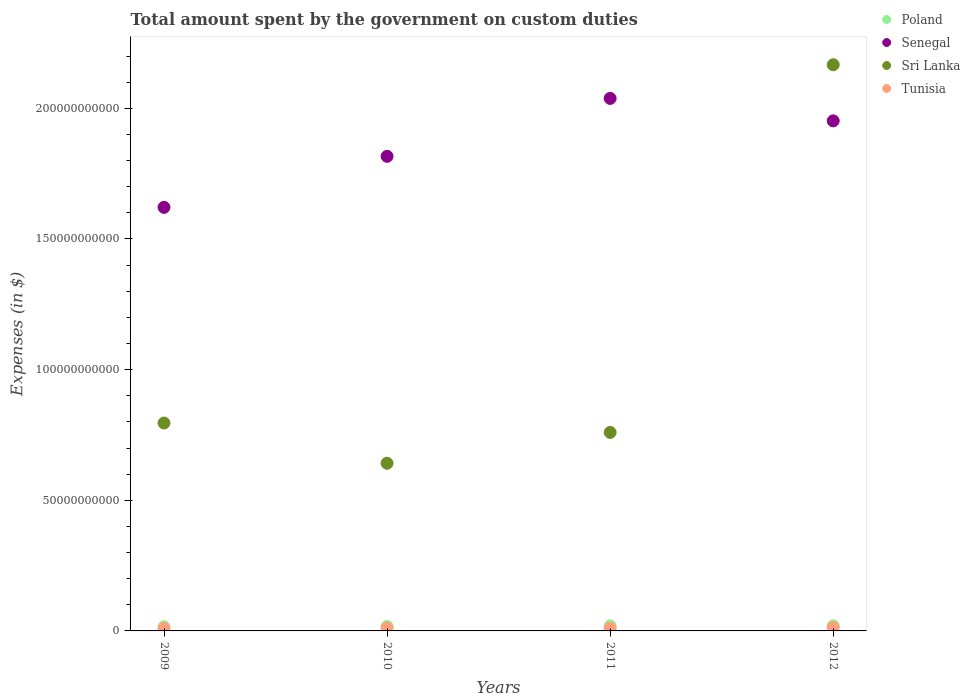What is the amount spent on custom duties by the government in Poland in 2012?
Your response must be concise. 1.95e+09. Across all years, what is the maximum amount spent on custom duties by the government in Tunisia?
Ensure brevity in your answer.  1.31e+09. Across all years, what is the minimum amount spent on custom duties by the government in Tunisia?
Offer a terse response. 9.72e+08. In which year was the amount spent on custom duties by the government in Poland maximum?
Keep it short and to the point. 2011. What is the total amount spent on custom duties by the government in Tunisia in the graph?
Provide a short and direct response. 4.47e+09. What is the difference between the amount spent on custom duties by the government in Sri Lanka in 2010 and that in 2011?
Provide a short and direct response. -1.18e+1. What is the difference between the amount spent on custom duties by the government in Poland in 2010 and the amount spent on custom duties by the government in Senegal in 2009?
Keep it short and to the point. -1.60e+11. What is the average amount spent on custom duties by the government in Tunisia per year?
Offer a very short reply. 1.12e+09. In the year 2010, what is the difference between the amount spent on custom duties by the government in Senegal and amount spent on custom duties by the government in Tunisia?
Keep it short and to the point. 1.80e+11. What is the ratio of the amount spent on custom duties by the government in Senegal in 2009 to that in 2012?
Your answer should be compact. 0.83. Is the difference between the amount spent on custom duties by the government in Senegal in 2010 and 2012 greater than the difference between the amount spent on custom duties by the government in Tunisia in 2010 and 2012?
Provide a succinct answer. No. What is the difference between the highest and the second highest amount spent on custom duties by the government in Sri Lanka?
Offer a terse response. 1.37e+11. What is the difference between the highest and the lowest amount spent on custom duties by the government in Poland?
Offer a terse response. 3.66e+08. Is the sum of the amount spent on custom duties by the government in Senegal in 2010 and 2011 greater than the maximum amount spent on custom duties by the government in Sri Lanka across all years?
Provide a short and direct response. Yes. Is it the case that in every year, the sum of the amount spent on custom duties by the government in Poland and amount spent on custom duties by the government in Senegal  is greater than the sum of amount spent on custom duties by the government in Tunisia and amount spent on custom duties by the government in Sri Lanka?
Provide a succinct answer. Yes. Does the amount spent on custom duties by the government in Poland monotonically increase over the years?
Make the answer very short. No. How many dotlines are there?
Keep it short and to the point. 4. What is the difference between two consecutive major ticks on the Y-axis?
Your response must be concise. 5.00e+1. Are the values on the major ticks of Y-axis written in scientific E-notation?
Keep it short and to the point. No. Does the graph contain grids?
Provide a succinct answer. No. How many legend labels are there?
Your answer should be very brief. 4. What is the title of the graph?
Your answer should be compact. Total amount spent by the government on custom duties. Does "Honduras" appear as one of the legend labels in the graph?
Your response must be concise. No. What is the label or title of the X-axis?
Offer a very short reply. Years. What is the label or title of the Y-axis?
Your response must be concise. Expenses (in $). What is the Expenses (in $) of Poland in 2009?
Offer a very short reply. 1.59e+09. What is the Expenses (in $) in Senegal in 2009?
Your answer should be compact. 1.62e+11. What is the Expenses (in $) in Sri Lanka in 2009?
Offer a very short reply. 7.96e+1. What is the Expenses (in $) in Tunisia in 2009?
Provide a succinct answer. 9.72e+08. What is the Expenses (in $) of Poland in 2010?
Keep it short and to the point. 1.69e+09. What is the Expenses (in $) in Senegal in 2010?
Your answer should be compact. 1.82e+11. What is the Expenses (in $) in Sri Lanka in 2010?
Your answer should be very brief. 6.42e+1. What is the Expenses (in $) in Tunisia in 2010?
Give a very brief answer. 1.13e+09. What is the Expenses (in $) in Poland in 2011?
Keep it short and to the point. 1.96e+09. What is the Expenses (in $) of Senegal in 2011?
Provide a succinct answer. 2.04e+11. What is the Expenses (in $) in Sri Lanka in 2011?
Offer a terse response. 7.60e+1. What is the Expenses (in $) of Tunisia in 2011?
Provide a succinct answer. 1.06e+09. What is the Expenses (in $) in Poland in 2012?
Offer a very short reply. 1.95e+09. What is the Expenses (in $) of Senegal in 2012?
Offer a terse response. 1.95e+11. What is the Expenses (in $) of Sri Lanka in 2012?
Your answer should be very brief. 2.17e+11. What is the Expenses (in $) in Tunisia in 2012?
Ensure brevity in your answer.  1.31e+09. Across all years, what is the maximum Expenses (in $) of Poland?
Keep it short and to the point. 1.96e+09. Across all years, what is the maximum Expenses (in $) of Senegal?
Ensure brevity in your answer.  2.04e+11. Across all years, what is the maximum Expenses (in $) in Sri Lanka?
Offer a very short reply. 2.17e+11. Across all years, what is the maximum Expenses (in $) in Tunisia?
Make the answer very short. 1.31e+09. Across all years, what is the minimum Expenses (in $) in Poland?
Provide a succinct answer. 1.59e+09. Across all years, what is the minimum Expenses (in $) in Senegal?
Offer a terse response. 1.62e+11. Across all years, what is the minimum Expenses (in $) of Sri Lanka?
Your response must be concise. 6.42e+1. Across all years, what is the minimum Expenses (in $) in Tunisia?
Provide a succinct answer. 9.72e+08. What is the total Expenses (in $) in Poland in the graph?
Your answer should be compact. 7.19e+09. What is the total Expenses (in $) of Senegal in the graph?
Provide a short and direct response. 7.43e+11. What is the total Expenses (in $) in Sri Lanka in the graph?
Your answer should be compact. 4.36e+11. What is the total Expenses (in $) in Tunisia in the graph?
Your answer should be compact. 4.47e+09. What is the difference between the Expenses (in $) of Poland in 2009 and that in 2010?
Your answer should be very brief. -1.05e+08. What is the difference between the Expenses (in $) in Senegal in 2009 and that in 2010?
Offer a very short reply. -1.95e+1. What is the difference between the Expenses (in $) of Sri Lanka in 2009 and that in 2010?
Give a very brief answer. 1.54e+1. What is the difference between the Expenses (in $) in Tunisia in 2009 and that in 2010?
Ensure brevity in your answer.  -1.53e+08. What is the difference between the Expenses (in $) in Poland in 2009 and that in 2011?
Keep it short and to the point. -3.66e+08. What is the difference between the Expenses (in $) of Senegal in 2009 and that in 2011?
Provide a short and direct response. -4.17e+1. What is the difference between the Expenses (in $) in Sri Lanka in 2009 and that in 2011?
Your response must be concise. 3.59e+09. What is the difference between the Expenses (in $) of Tunisia in 2009 and that in 2011?
Offer a very short reply. -8.71e+07. What is the difference between the Expenses (in $) of Poland in 2009 and that in 2012?
Your answer should be very brief. -3.61e+08. What is the difference between the Expenses (in $) in Senegal in 2009 and that in 2012?
Your answer should be very brief. -3.31e+1. What is the difference between the Expenses (in $) of Sri Lanka in 2009 and that in 2012?
Your answer should be very brief. -1.37e+11. What is the difference between the Expenses (in $) of Tunisia in 2009 and that in 2012?
Offer a very short reply. -3.41e+08. What is the difference between the Expenses (in $) of Poland in 2010 and that in 2011?
Provide a succinct answer. -2.61e+08. What is the difference between the Expenses (in $) in Senegal in 2010 and that in 2011?
Offer a very short reply. -2.22e+1. What is the difference between the Expenses (in $) of Sri Lanka in 2010 and that in 2011?
Your answer should be compact. -1.18e+1. What is the difference between the Expenses (in $) of Tunisia in 2010 and that in 2011?
Give a very brief answer. 6.62e+07. What is the difference between the Expenses (in $) in Poland in 2010 and that in 2012?
Ensure brevity in your answer.  -2.56e+08. What is the difference between the Expenses (in $) of Senegal in 2010 and that in 2012?
Your answer should be very brief. -1.36e+1. What is the difference between the Expenses (in $) of Sri Lanka in 2010 and that in 2012?
Provide a succinct answer. -1.53e+11. What is the difference between the Expenses (in $) in Tunisia in 2010 and that in 2012?
Keep it short and to the point. -1.88e+08. What is the difference between the Expenses (in $) in Poland in 2011 and that in 2012?
Give a very brief answer. 5.00e+06. What is the difference between the Expenses (in $) in Senegal in 2011 and that in 2012?
Offer a very short reply. 8.60e+09. What is the difference between the Expenses (in $) in Sri Lanka in 2011 and that in 2012?
Keep it short and to the point. -1.41e+11. What is the difference between the Expenses (in $) in Tunisia in 2011 and that in 2012?
Give a very brief answer. -2.54e+08. What is the difference between the Expenses (in $) in Poland in 2009 and the Expenses (in $) in Senegal in 2010?
Provide a succinct answer. -1.80e+11. What is the difference between the Expenses (in $) in Poland in 2009 and the Expenses (in $) in Sri Lanka in 2010?
Ensure brevity in your answer.  -6.26e+1. What is the difference between the Expenses (in $) in Poland in 2009 and the Expenses (in $) in Tunisia in 2010?
Your answer should be very brief. 4.64e+08. What is the difference between the Expenses (in $) in Senegal in 2009 and the Expenses (in $) in Sri Lanka in 2010?
Your answer should be very brief. 9.79e+1. What is the difference between the Expenses (in $) of Senegal in 2009 and the Expenses (in $) of Tunisia in 2010?
Give a very brief answer. 1.61e+11. What is the difference between the Expenses (in $) in Sri Lanka in 2009 and the Expenses (in $) in Tunisia in 2010?
Offer a terse response. 7.84e+1. What is the difference between the Expenses (in $) of Poland in 2009 and the Expenses (in $) of Senegal in 2011?
Provide a short and direct response. -2.02e+11. What is the difference between the Expenses (in $) in Poland in 2009 and the Expenses (in $) in Sri Lanka in 2011?
Give a very brief answer. -7.44e+1. What is the difference between the Expenses (in $) in Poland in 2009 and the Expenses (in $) in Tunisia in 2011?
Make the answer very short. 5.30e+08. What is the difference between the Expenses (in $) in Senegal in 2009 and the Expenses (in $) in Sri Lanka in 2011?
Provide a succinct answer. 8.61e+1. What is the difference between the Expenses (in $) of Senegal in 2009 and the Expenses (in $) of Tunisia in 2011?
Ensure brevity in your answer.  1.61e+11. What is the difference between the Expenses (in $) in Sri Lanka in 2009 and the Expenses (in $) in Tunisia in 2011?
Make the answer very short. 7.85e+1. What is the difference between the Expenses (in $) in Poland in 2009 and the Expenses (in $) in Senegal in 2012?
Your answer should be very brief. -1.94e+11. What is the difference between the Expenses (in $) in Poland in 2009 and the Expenses (in $) in Sri Lanka in 2012?
Keep it short and to the point. -2.15e+11. What is the difference between the Expenses (in $) of Poland in 2009 and the Expenses (in $) of Tunisia in 2012?
Give a very brief answer. 2.76e+08. What is the difference between the Expenses (in $) in Senegal in 2009 and the Expenses (in $) in Sri Lanka in 2012?
Your answer should be very brief. -5.46e+1. What is the difference between the Expenses (in $) of Senegal in 2009 and the Expenses (in $) of Tunisia in 2012?
Provide a succinct answer. 1.61e+11. What is the difference between the Expenses (in $) of Sri Lanka in 2009 and the Expenses (in $) of Tunisia in 2012?
Ensure brevity in your answer.  7.82e+1. What is the difference between the Expenses (in $) in Poland in 2010 and the Expenses (in $) in Senegal in 2011?
Make the answer very short. -2.02e+11. What is the difference between the Expenses (in $) in Poland in 2010 and the Expenses (in $) in Sri Lanka in 2011?
Ensure brevity in your answer.  -7.43e+1. What is the difference between the Expenses (in $) of Poland in 2010 and the Expenses (in $) of Tunisia in 2011?
Your answer should be very brief. 6.35e+08. What is the difference between the Expenses (in $) of Senegal in 2010 and the Expenses (in $) of Sri Lanka in 2011?
Your response must be concise. 1.06e+11. What is the difference between the Expenses (in $) of Senegal in 2010 and the Expenses (in $) of Tunisia in 2011?
Keep it short and to the point. 1.81e+11. What is the difference between the Expenses (in $) in Sri Lanka in 2010 and the Expenses (in $) in Tunisia in 2011?
Provide a short and direct response. 6.31e+1. What is the difference between the Expenses (in $) of Poland in 2010 and the Expenses (in $) of Senegal in 2012?
Ensure brevity in your answer.  -1.94e+11. What is the difference between the Expenses (in $) in Poland in 2010 and the Expenses (in $) in Sri Lanka in 2012?
Your response must be concise. -2.15e+11. What is the difference between the Expenses (in $) of Poland in 2010 and the Expenses (in $) of Tunisia in 2012?
Your answer should be compact. 3.81e+08. What is the difference between the Expenses (in $) in Senegal in 2010 and the Expenses (in $) in Sri Lanka in 2012?
Give a very brief answer. -3.50e+1. What is the difference between the Expenses (in $) of Senegal in 2010 and the Expenses (in $) of Tunisia in 2012?
Provide a succinct answer. 1.80e+11. What is the difference between the Expenses (in $) in Sri Lanka in 2010 and the Expenses (in $) in Tunisia in 2012?
Provide a short and direct response. 6.28e+1. What is the difference between the Expenses (in $) of Poland in 2011 and the Expenses (in $) of Senegal in 2012?
Offer a terse response. -1.93e+11. What is the difference between the Expenses (in $) of Poland in 2011 and the Expenses (in $) of Sri Lanka in 2012?
Make the answer very short. -2.15e+11. What is the difference between the Expenses (in $) of Poland in 2011 and the Expenses (in $) of Tunisia in 2012?
Your response must be concise. 6.42e+08. What is the difference between the Expenses (in $) of Senegal in 2011 and the Expenses (in $) of Sri Lanka in 2012?
Give a very brief answer. -1.29e+1. What is the difference between the Expenses (in $) of Senegal in 2011 and the Expenses (in $) of Tunisia in 2012?
Your answer should be compact. 2.02e+11. What is the difference between the Expenses (in $) in Sri Lanka in 2011 and the Expenses (in $) in Tunisia in 2012?
Your response must be concise. 7.47e+1. What is the average Expenses (in $) of Poland per year?
Ensure brevity in your answer.  1.80e+09. What is the average Expenses (in $) of Senegal per year?
Offer a terse response. 1.86e+11. What is the average Expenses (in $) in Sri Lanka per year?
Your response must be concise. 1.09e+11. What is the average Expenses (in $) in Tunisia per year?
Give a very brief answer. 1.12e+09. In the year 2009, what is the difference between the Expenses (in $) in Poland and Expenses (in $) in Senegal?
Ensure brevity in your answer.  -1.61e+11. In the year 2009, what is the difference between the Expenses (in $) in Poland and Expenses (in $) in Sri Lanka?
Provide a short and direct response. -7.80e+1. In the year 2009, what is the difference between the Expenses (in $) of Poland and Expenses (in $) of Tunisia?
Your response must be concise. 6.17e+08. In the year 2009, what is the difference between the Expenses (in $) of Senegal and Expenses (in $) of Sri Lanka?
Make the answer very short. 8.25e+1. In the year 2009, what is the difference between the Expenses (in $) of Senegal and Expenses (in $) of Tunisia?
Give a very brief answer. 1.61e+11. In the year 2009, what is the difference between the Expenses (in $) of Sri Lanka and Expenses (in $) of Tunisia?
Provide a short and direct response. 7.86e+1. In the year 2010, what is the difference between the Expenses (in $) of Poland and Expenses (in $) of Senegal?
Provide a succinct answer. -1.80e+11. In the year 2010, what is the difference between the Expenses (in $) of Poland and Expenses (in $) of Sri Lanka?
Provide a short and direct response. -6.25e+1. In the year 2010, what is the difference between the Expenses (in $) of Poland and Expenses (in $) of Tunisia?
Your answer should be compact. 5.69e+08. In the year 2010, what is the difference between the Expenses (in $) in Senegal and Expenses (in $) in Sri Lanka?
Your answer should be compact. 1.17e+11. In the year 2010, what is the difference between the Expenses (in $) of Senegal and Expenses (in $) of Tunisia?
Give a very brief answer. 1.80e+11. In the year 2010, what is the difference between the Expenses (in $) of Sri Lanka and Expenses (in $) of Tunisia?
Your response must be concise. 6.30e+1. In the year 2011, what is the difference between the Expenses (in $) in Poland and Expenses (in $) in Senegal?
Offer a terse response. -2.02e+11. In the year 2011, what is the difference between the Expenses (in $) in Poland and Expenses (in $) in Sri Lanka?
Give a very brief answer. -7.40e+1. In the year 2011, what is the difference between the Expenses (in $) in Poland and Expenses (in $) in Tunisia?
Keep it short and to the point. 8.96e+08. In the year 2011, what is the difference between the Expenses (in $) in Senegal and Expenses (in $) in Sri Lanka?
Keep it short and to the point. 1.28e+11. In the year 2011, what is the difference between the Expenses (in $) in Senegal and Expenses (in $) in Tunisia?
Ensure brevity in your answer.  2.03e+11. In the year 2011, what is the difference between the Expenses (in $) of Sri Lanka and Expenses (in $) of Tunisia?
Your answer should be very brief. 7.49e+1. In the year 2012, what is the difference between the Expenses (in $) of Poland and Expenses (in $) of Senegal?
Offer a terse response. -1.93e+11. In the year 2012, what is the difference between the Expenses (in $) of Poland and Expenses (in $) of Sri Lanka?
Keep it short and to the point. -2.15e+11. In the year 2012, what is the difference between the Expenses (in $) of Poland and Expenses (in $) of Tunisia?
Give a very brief answer. 6.37e+08. In the year 2012, what is the difference between the Expenses (in $) of Senegal and Expenses (in $) of Sri Lanka?
Offer a very short reply. -2.15e+1. In the year 2012, what is the difference between the Expenses (in $) of Senegal and Expenses (in $) of Tunisia?
Make the answer very short. 1.94e+11. In the year 2012, what is the difference between the Expenses (in $) in Sri Lanka and Expenses (in $) in Tunisia?
Provide a succinct answer. 2.15e+11. What is the ratio of the Expenses (in $) in Poland in 2009 to that in 2010?
Your response must be concise. 0.94. What is the ratio of the Expenses (in $) in Senegal in 2009 to that in 2010?
Keep it short and to the point. 0.89. What is the ratio of the Expenses (in $) in Sri Lanka in 2009 to that in 2010?
Keep it short and to the point. 1.24. What is the ratio of the Expenses (in $) in Tunisia in 2009 to that in 2010?
Your answer should be compact. 0.86. What is the ratio of the Expenses (in $) in Poland in 2009 to that in 2011?
Your response must be concise. 0.81. What is the ratio of the Expenses (in $) of Senegal in 2009 to that in 2011?
Provide a succinct answer. 0.8. What is the ratio of the Expenses (in $) of Sri Lanka in 2009 to that in 2011?
Provide a succinct answer. 1.05. What is the ratio of the Expenses (in $) of Tunisia in 2009 to that in 2011?
Your response must be concise. 0.92. What is the ratio of the Expenses (in $) of Poland in 2009 to that in 2012?
Ensure brevity in your answer.  0.81. What is the ratio of the Expenses (in $) of Senegal in 2009 to that in 2012?
Keep it short and to the point. 0.83. What is the ratio of the Expenses (in $) of Sri Lanka in 2009 to that in 2012?
Offer a terse response. 0.37. What is the ratio of the Expenses (in $) of Tunisia in 2009 to that in 2012?
Offer a very short reply. 0.74. What is the ratio of the Expenses (in $) in Poland in 2010 to that in 2011?
Offer a very short reply. 0.87. What is the ratio of the Expenses (in $) in Senegal in 2010 to that in 2011?
Provide a succinct answer. 0.89. What is the ratio of the Expenses (in $) in Sri Lanka in 2010 to that in 2011?
Offer a very short reply. 0.84. What is the ratio of the Expenses (in $) in Poland in 2010 to that in 2012?
Make the answer very short. 0.87. What is the ratio of the Expenses (in $) of Senegal in 2010 to that in 2012?
Give a very brief answer. 0.93. What is the ratio of the Expenses (in $) of Sri Lanka in 2010 to that in 2012?
Keep it short and to the point. 0.3. What is the ratio of the Expenses (in $) of Tunisia in 2010 to that in 2012?
Ensure brevity in your answer.  0.86. What is the ratio of the Expenses (in $) of Poland in 2011 to that in 2012?
Ensure brevity in your answer.  1. What is the ratio of the Expenses (in $) of Senegal in 2011 to that in 2012?
Your answer should be very brief. 1.04. What is the ratio of the Expenses (in $) in Sri Lanka in 2011 to that in 2012?
Keep it short and to the point. 0.35. What is the ratio of the Expenses (in $) in Tunisia in 2011 to that in 2012?
Your answer should be compact. 0.81. What is the difference between the highest and the second highest Expenses (in $) of Poland?
Your response must be concise. 5.00e+06. What is the difference between the highest and the second highest Expenses (in $) of Senegal?
Keep it short and to the point. 8.60e+09. What is the difference between the highest and the second highest Expenses (in $) of Sri Lanka?
Your answer should be very brief. 1.37e+11. What is the difference between the highest and the second highest Expenses (in $) of Tunisia?
Ensure brevity in your answer.  1.88e+08. What is the difference between the highest and the lowest Expenses (in $) in Poland?
Make the answer very short. 3.66e+08. What is the difference between the highest and the lowest Expenses (in $) of Senegal?
Provide a short and direct response. 4.17e+1. What is the difference between the highest and the lowest Expenses (in $) of Sri Lanka?
Keep it short and to the point. 1.53e+11. What is the difference between the highest and the lowest Expenses (in $) of Tunisia?
Make the answer very short. 3.41e+08. 